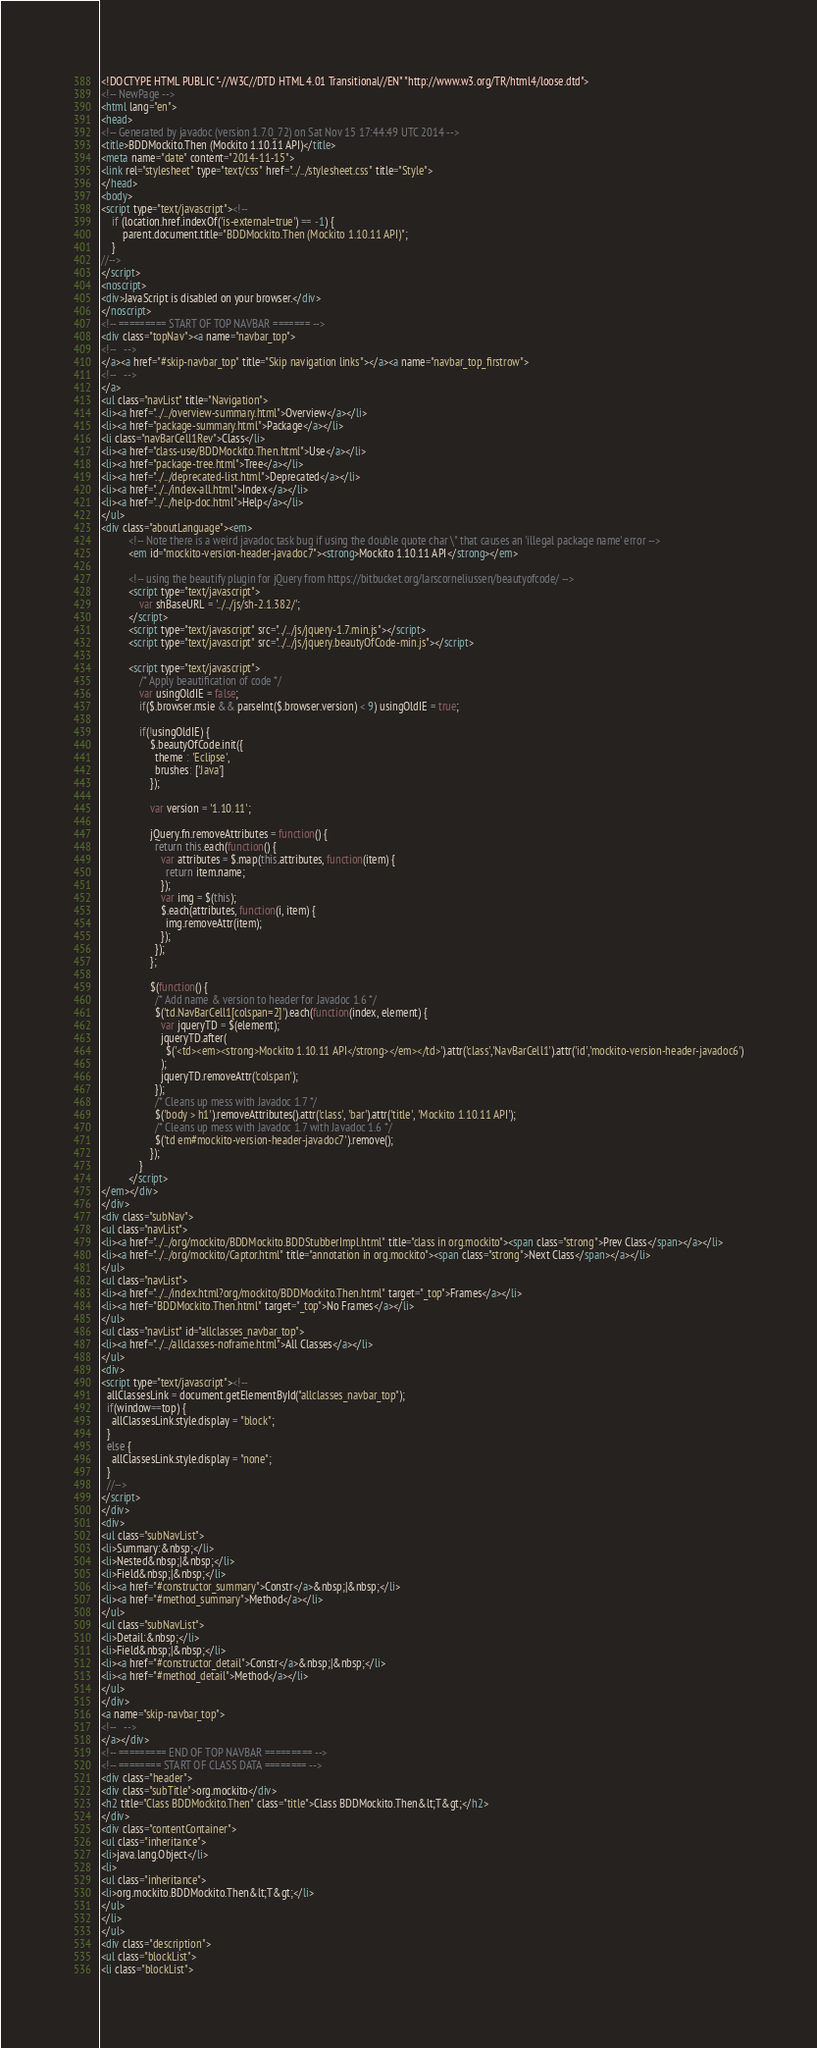Convert code to text. <code><loc_0><loc_0><loc_500><loc_500><_HTML_><!DOCTYPE HTML PUBLIC "-//W3C//DTD HTML 4.01 Transitional//EN" "http://www.w3.org/TR/html4/loose.dtd">
<!-- NewPage -->
<html lang="en">
<head>
<!-- Generated by javadoc (version 1.7.0_72) on Sat Nov 15 17:44:49 UTC 2014 -->
<title>BDDMockito.Then (Mockito 1.10.11 API)</title>
<meta name="date" content="2014-11-15">
<link rel="stylesheet" type="text/css" href="../../stylesheet.css" title="Style">
</head>
<body>
<script type="text/javascript"><!--
    if (location.href.indexOf('is-external=true') == -1) {
        parent.document.title="BDDMockito.Then (Mockito 1.10.11 API)";
    }
//-->
</script>
<noscript>
<div>JavaScript is disabled on your browser.</div>
</noscript>
<!-- ========= START OF TOP NAVBAR ======= -->
<div class="topNav"><a name="navbar_top">
<!--   -->
</a><a href="#skip-navbar_top" title="Skip navigation links"></a><a name="navbar_top_firstrow">
<!--   -->
</a>
<ul class="navList" title="Navigation">
<li><a href="../../overview-summary.html">Overview</a></li>
<li><a href="package-summary.html">Package</a></li>
<li class="navBarCell1Rev">Class</li>
<li><a href="class-use/BDDMockito.Then.html">Use</a></li>
<li><a href="package-tree.html">Tree</a></li>
<li><a href="../../deprecated-list.html">Deprecated</a></li>
<li><a href="../../index-all.html">Index</a></li>
<li><a href="../../help-doc.html">Help</a></li>
</ul>
<div class="aboutLanguage"><em>
          <!-- Note there is a weird javadoc task bug if using the double quote char \" that causes an 'illegal package name' error -->
          <em id="mockito-version-header-javadoc7"><strong>Mockito 1.10.11 API</strong></em>

          <!-- using the beautify plugin for jQuery from https://bitbucket.org/larscorneliussen/beautyofcode/ -->
          <script type="text/javascript">
              var shBaseURL = '../../js/sh-2.1.382/';
          </script>
          <script type="text/javascript" src="../../js/jquery-1.7.min.js"></script>
          <script type="text/javascript" src="../../js/jquery.beautyOfCode-min.js"></script>

          <script type="text/javascript">
              /* Apply beautification of code */
              var usingOldIE = false;
              if($.browser.msie && parseInt($.browser.version) < 9) usingOldIE = true;

              if(!usingOldIE) {
                  $.beautyOfCode.init({
                    theme : 'Eclipse',
                    brushes: ['Java']
                  });

                  var version = '1.10.11';

                  jQuery.fn.removeAttributes = function() {
                    return this.each(function() {
                      var attributes = $.map(this.attributes, function(item) {
                        return item.name;
                      });
                      var img = $(this);
                      $.each(attributes, function(i, item) {
                        img.removeAttr(item);
                      });
                    });
                  };

                  $(function() {
                    /* Add name & version to header for Javadoc 1.6 */
                    $('td.NavBarCell1[colspan=2]').each(function(index, element) {
                      var jqueryTD = $(element);
                      jqueryTD.after(
                        $('<td><em><strong>Mockito 1.10.11 API</strong></em></td>').attr('class','NavBarCell1').attr('id','mockito-version-header-javadoc6')
                      );
                      jqueryTD.removeAttr('colspan');
                    });
                    /* Cleans up mess with Javadoc 1.7 */
                    $('body > h1').removeAttributes().attr('class', 'bar').attr('title', 'Mockito 1.10.11 API');
                    /* Cleans up mess with Javadoc 1.7 with Javadoc 1.6 */
                    $('td em#mockito-version-header-javadoc7').remove();
                  });
              }
          </script>
</em></div>
</div>
<div class="subNav">
<ul class="navList">
<li><a href="../../org/mockito/BDDMockito.BDDStubberImpl.html" title="class in org.mockito"><span class="strong">Prev Class</span></a></li>
<li><a href="../../org/mockito/Captor.html" title="annotation in org.mockito"><span class="strong">Next Class</span></a></li>
</ul>
<ul class="navList">
<li><a href="../../index.html?org/mockito/BDDMockito.Then.html" target="_top">Frames</a></li>
<li><a href="BDDMockito.Then.html" target="_top">No Frames</a></li>
</ul>
<ul class="navList" id="allclasses_navbar_top">
<li><a href="../../allclasses-noframe.html">All Classes</a></li>
</ul>
<div>
<script type="text/javascript"><!--
  allClassesLink = document.getElementById("allclasses_navbar_top");
  if(window==top) {
    allClassesLink.style.display = "block";
  }
  else {
    allClassesLink.style.display = "none";
  }
  //-->
</script>
</div>
<div>
<ul class="subNavList">
<li>Summary:&nbsp;</li>
<li>Nested&nbsp;|&nbsp;</li>
<li>Field&nbsp;|&nbsp;</li>
<li><a href="#constructor_summary">Constr</a>&nbsp;|&nbsp;</li>
<li><a href="#method_summary">Method</a></li>
</ul>
<ul class="subNavList">
<li>Detail:&nbsp;</li>
<li>Field&nbsp;|&nbsp;</li>
<li><a href="#constructor_detail">Constr</a>&nbsp;|&nbsp;</li>
<li><a href="#method_detail">Method</a></li>
</ul>
</div>
<a name="skip-navbar_top">
<!--   -->
</a></div>
<!-- ========= END OF TOP NAVBAR ========= -->
<!-- ======== START OF CLASS DATA ======== -->
<div class="header">
<div class="subTitle">org.mockito</div>
<h2 title="Class BDDMockito.Then" class="title">Class BDDMockito.Then&lt;T&gt;</h2>
</div>
<div class="contentContainer">
<ul class="inheritance">
<li>java.lang.Object</li>
<li>
<ul class="inheritance">
<li>org.mockito.BDDMockito.Then&lt;T&gt;</li>
</ul>
</li>
</ul>
<div class="description">
<ul class="blockList">
<li class="blockList"></code> 